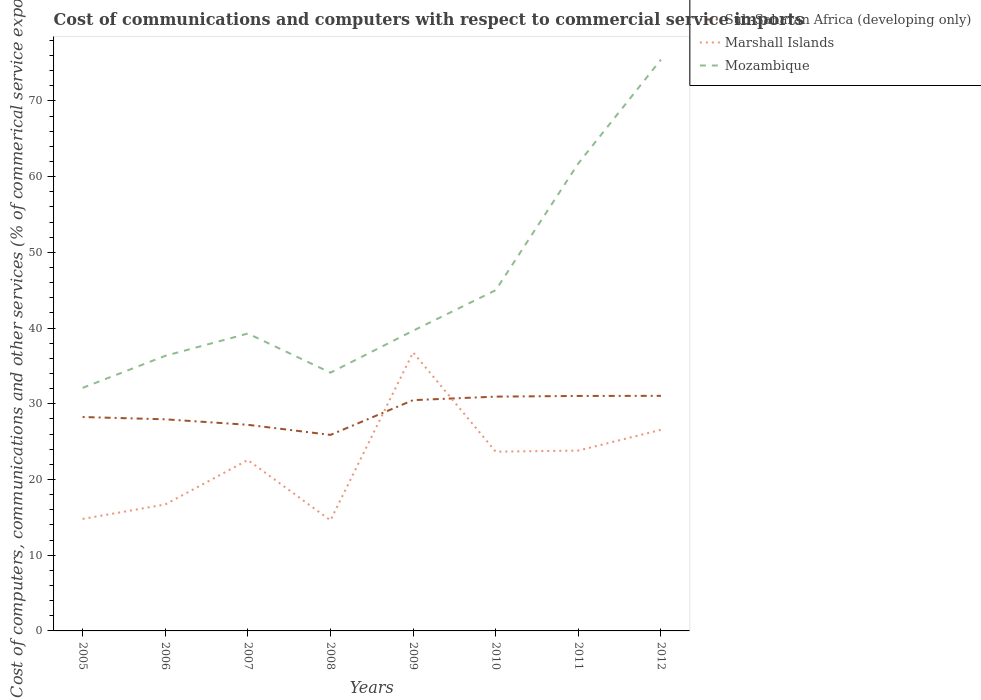Across all years, what is the maximum cost of communications and computers in Marshall Islands?
Ensure brevity in your answer.  14.61. In which year was the cost of communications and computers in Mozambique maximum?
Ensure brevity in your answer.  2005. What is the total cost of communications and computers in Sub-Saharan Africa (developing only) in the graph?
Your response must be concise. -3.1. What is the difference between the highest and the second highest cost of communications and computers in Marshall Islands?
Your response must be concise. 22.18. Is the cost of communications and computers in Marshall Islands strictly greater than the cost of communications and computers in Mozambique over the years?
Keep it short and to the point. Yes. How many lines are there?
Ensure brevity in your answer.  3. How many years are there in the graph?
Your response must be concise. 8. What is the difference between two consecutive major ticks on the Y-axis?
Your response must be concise. 10. Are the values on the major ticks of Y-axis written in scientific E-notation?
Keep it short and to the point. No. Does the graph contain any zero values?
Your answer should be very brief. No. Does the graph contain grids?
Give a very brief answer. No. Where does the legend appear in the graph?
Provide a short and direct response. Top right. How are the legend labels stacked?
Keep it short and to the point. Vertical. What is the title of the graph?
Your answer should be compact. Cost of communications and computers with respect to commercial service imports. What is the label or title of the X-axis?
Ensure brevity in your answer.  Years. What is the label or title of the Y-axis?
Your response must be concise. Cost of computers, communications and other services (% of commerical service exports). What is the Cost of computers, communications and other services (% of commerical service exports) in Sub-Saharan Africa (developing only) in 2005?
Your answer should be very brief. 28.25. What is the Cost of computers, communications and other services (% of commerical service exports) of Marshall Islands in 2005?
Your answer should be compact. 14.79. What is the Cost of computers, communications and other services (% of commerical service exports) of Mozambique in 2005?
Your response must be concise. 32.1. What is the Cost of computers, communications and other services (% of commerical service exports) in Sub-Saharan Africa (developing only) in 2006?
Offer a terse response. 27.95. What is the Cost of computers, communications and other services (% of commerical service exports) in Marshall Islands in 2006?
Give a very brief answer. 16.7. What is the Cost of computers, communications and other services (% of commerical service exports) of Mozambique in 2006?
Your answer should be very brief. 36.33. What is the Cost of computers, communications and other services (% of commerical service exports) in Sub-Saharan Africa (developing only) in 2007?
Your answer should be compact. 27.22. What is the Cost of computers, communications and other services (% of commerical service exports) in Marshall Islands in 2007?
Your answer should be very brief. 22.57. What is the Cost of computers, communications and other services (% of commerical service exports) of Mozambique in 2007?
Your response must be concise. 39.27. What is the Cost of computers, communications and other services (% of commerical service exports) in Sub-Saharan Africa (developing only) in 2008?
Provide a short and direct response. 25.89. What is the Cost of computers, communications and other services (% of commerical service exports) in Marshall Islands in 2008?
Your answer should be very brief. 14.61. What is the Cost of computers, communications and other services (% of commerical service exports) in Mozambique in 2008?
Give a very brief answer. 34.11. What is the Cost of computers, communications and other services (% of commerical service exports) in Sub-Saharan Africa (developing only) in 2009?
Provide a short and direct response. 30.48. What is the Cost of computers, communications and other services (% of commerical service exports) in Marshall Islands in 2009?
Give a very brief answer. 36.79. What is the Cost of computers, communications and other services (% of commerical service exports) in Mozambique in 2009?
Your answer should be compact. 39.64. What is the Cost of computers, communications and other services (% of commerical service exports) of Sub-Saharan Africa (developing only) in 2010?
Make the answer very short. 30.94. What is the Cost of computers, communications and other services (% of commerical service exports) of Marshall Islands in 2010?
Your answer should be compact. 23.67. What is the Cost of computers, communications and other services (% of commerical service exports) in Mozambique in 2010?
Give a very brief answer. 45. What is the Cost of computers, communications and other services (% of commerical service exports) of Sub-Saharan Africa (developing only) in 2011?
Provide a short and direct response. 31.03. What is the Cost of computers, communications and other services (% of commerical service exports) of Marshall Islands in 2011?
Offer a terse response. 23.82. What is the Cost of computers, communications and other services (% of commerical service exports) in Mozambique in 2011?
Provide a short and direct response. 61.74. What is the Cost of computers, communications and other services (% of commerical service exports) of Sub-Saharan Africa (developing only) in 2012?
Give a very brief answer. 31.05. What is the Cost of computers, communications and other services (% of commerical service exports) in Marshall Islands in 2012?
Provide a short and direct response. 26.56. What is the Cost of computers, communications and other services (% of commerical service exports) of Mozambique in 2012?
Keep it short and to the point. 75.45. Across all years, what is the maximum Cost of computers, communications and other services (% of commerical service exports) of Sub-Saharan Africa (developing only)?
Give a very brief answer. 31.05. Across all years, what is the maximum Cost of computers, communications and other services (% of commerical service exports) of Marshall Islands?
Provide a short and direct response. 36.79. Across all years, what is the maximum Cost of computers, communications and other services (% of commerical service exports) in Mozambique?
Your answer should be very brief. 75.45. Across all years, what is the minimum Cost of computers, communications and other services (% of commerical service exports) of Sub-Saharan Africa (developing only)?
Your answer should be compact. 25.89. Across all years, what is the minimum Cost of computers, communications and other services (% of commerical service exports) of Marshall Islands?
Provide a short and direct response. 14.61. Across all years, what is the minimum Cost of computers, communications and other services (% of commerical service exports) in Mozambique?
Your answer should be compact. 32.1. What is the total Cost of computers, communications and other services (% of commerical service exports) in Sub-Saharan Africa (developing only) in the graph?
Offer a very short reply. 232.8. What is the total Cost of computers, communications and other services (% of commerical service exports) of Marshall Islands in the graph?
Offer a terse response. 179.5. What is the total Cost of computers, communications and other services (% of commerical service exports) of Mozambique in the graph?
Provide a short and direct response. 363.64. What is the difference between the Cost of computers, communications and other services (% of commerical service exports) in Sub-Saharan Africa (developing only) in 2005 and that in 2006?
Your response must be concise. 0.3. What is the difference between the Cost of computers, communications and other services (% of commerical service exports) in Marshall Islands in 2005 and that in 2006?
Your response must be concise. -1.91. What is the difference between the Cost of computers, communications and other services (% of commerical service exports) of Mozambique in 2005 and that in 2006?
Provide a succinct answer. -4.23. What is the difference between the Cost of computers, communications and other services (% of commerical service exports) in Sub-Saharan Africa (developing only) in 2005 and that in 2007?
Ensure brevity in your answer.  1.03. What is the difference between the Cost of computers, communications and other services (% of commerical service exports) in Marshall Islands in 2005 and that in 2007?
Provide a short and direct response. -7.79. What is the difference between the Cost of computers, communications and other services (% of commerical service exports) in Mozambique in 2005 and that in 2007?
Give a very brief answer. -7.17. What is the difference between the Cost of computers, communications and other services (% of commerical service exports) in Sub-Saharan Africa (developing only) in 2005 and that in 2008?
Provide a succinct answer. 2.36. What is the difference between the Cost of computers, communications and other services (% of commerical service exports) in Marshall Islands in 2005 and that in 2008?
Make the answer very short. 0.18. What is the difference between the Cost of computers, communications and other services (% of commerical service exports) of Mozambique in 2005 and that in 2008?
Make the answer very short. -2.01. What is the difference between the Cost of computers, communications and other services (% of commerical service exports) in Sub-Saharan Africa (developing only) in 2005 and that in 2009?
Give a very brief answer. -2.23. What is the difference between the Cost of computers, communications and other services (% of commerical service exports) of Marshall Islands in 2005 and that in 2009?
Provide a succinct answer. -22. What is the difference between the Cost of computers, communications and other services (% of commerical service exports) in Mozambique in 2005 and that in 2009?
Provide a succinct answer. -7.54. What is the difference between the Cost of computers, communications and other services (% of commerical service exports) in Sub-Saharan Africa (developing only) in 2005 and that in 2010?
Offer a terse response. -2.69. What is the difference between the Cost of computers, communications and other services (% of commerical service exports) in Marshall Islands in 2005 and that in 2010?
Keep it short and to the point. -8.88. What is the difference between the Cost of computers, communications and other services (% of commerical service exports) of Sub-Saharan Africa (developing only) in 2005 and that in 2011?
Provide a succinct answer. -2.78. What is the difference between the Cost of computers, communications and other services (% of commerical service exports) in Marshall Islands in 2005 and that in 2011?
Provide a short and direct response. -9.03. What is the difference between the Cost of computers, communications and other services (% of commerical service exports) in Mozambique in 2005 and that in 2011?
Your answer should be compact. -29.64. What is the difference between the Cost of computers, communications and other services (% of commerical service exports) of Sub-Saharan Africa (developing only) in 2005 and that in 2012?
Offer a very short reply. -2.8. What is the difference between the Cost of computers, communications and other services (% of commerical service exports) in Marshall Islands in 2005 and that in 2012?
Your answer should be very brief. -11.77. What is the difference between the Cost of computers, communications and other services (% of commerical service exports) in Mozambique in 2005 and that in 2012?
Keep it short and to the point. -43.35. What is the difference between the Cost of computers, communications and other services (% of commerical service exports) of Sub-Saharan Africa (developing only) in 2006 and that in 2007?
Offer a very short reply. 0.73. What is the difference between the Cost of computers, communications and other services (% of commerical service exports) in Marshall Islands in 2006 and that in 2007?
Make the answer very short. -5.87. What is the difference between the Cost of computers, communications and other services (% of commerical service exports) of Mozambique in 2006 and that in 2007?
Offer a terse response. -2.94. What is the difference between the Cost of computers, communications and other services (% of commerical service exports) of Sub-Saharan Africa (developing only) in 2006 and that in 2008?
Keep it short and to the point. 2.06. What is the difference between the Cost of computers, communications and other services (% of commerical service exports) of Marshall Islands in 2006 and that in 2008?
Provide a short and direct response. 2.1. What is the difference between the Cost of computers, communications and other services (% of commerical service exports) of Mozambique in 2006 and that in 2008?
Offer a terse response. 2.22. What is the difference between the Cost of computers, communications and other services (% of commerical service exports) of Sub-Saharan Africa (developing only) in 2006 and that in 2009?
Make the answer very short. -2.53. What is the difference between the Cost of computers, communications and other services (% of commerical service exports) in Marshall Islands in 2006 and that in 2009?
Make the answer very short. -20.09. What is the difference between the Cost of computers, communications and other services (% of commerical service exports) in Mozambique in 2006 and that in 2009?
Provide a succinct answer. -3.31. What is the difference between the Cost of computers, communications and other services (% of commerical service exports) in Sub-Saharan Africa (developing only) in 2006 and that in 2010?
Offer a terse response. -3. What is the difference between the Cost of computers, communications and other services (% of commerical service exports) in Marshall Islands in 2006 and that in 2010?
Your answer should be compact. -6.97. What is the difference between the Cost of computers, communications and other services (% of commerical service exports) in Mozambique in 2006 and that in 2010?
Make the answer very short. -8.67. What is the difference between the Cost of computers, communications and other services (% of commerical service exports) of Sub-Saharan Africa (developing only) in 2006 and that in 2011?
Your response must be concise. -3.09. What is the difference between the Cost of computers, communications and other services (% of commerical service exports) of Marshall Islands in 2006 and that in 2011?
Provide a short and direct response. -7.11. What is the difference between the Cost of computers, communications and other services (% of commerical service exports) of Mozambique in 2006 and that in 2011?
Ensure brevity in your answer.  -25.41. What is the difference between the Cost of computers, communications and other services (% of commerical service exports) in Sub-Saharan Africa (developing only) in 2006 and that in 2012?
Provide a succinct answer. -3.1. What is the difference between the Cost of computers, communications and other services (% of commerical service exports) of Marshall Islands in 2006 and that in 2012?
Offer a very short reply. -9.86. What is the difference between the Cost of computers, communications and other services (% of commerical service exports) in Mozambique in 2006 and that in 2012?
Your response must be concise. -39.12. What is the difference between the Cost of computers, communications and other services (% of commerical service exports) of Sub-Saharan Africa (developing only) in 2007 and that in 2008?
Make the answer very short. 1.33. What is the difference between the Cost of computers, communications and other services (% of commerical service exports) of Marshall Islands in 2007 and that in 2008?
Make the answer very short. 7.97. What is the difference between the Cost of computers, communications and other services (% of commerical service exports) in Mozambique in 2007 and that in 2008?
Offer a terse response. 5.17. What is the difference between the Cost of computers, communications and other services (% of commerical service exports) of Sub-Saharan Africa (developing only) in 2007 and that in 2009?
Your response must be concise. -3.26. What is the difference between the Cost of computers, communications and other services (% of commerical service exports) of Marshall Islands in 2007 and that in 2009?
Your answer should be compact. -14.21. What is the difference between the Cost of computers, communications and other services (% of commerical service exports) of Mozambique in 2007 and that in 2009?
Offer a very short reply. -0.37. What is the difference between the Cost of computers, communications and other services (% of commerical service exports) in Sub-Saharan Africa (developing only) in 2007 and that in 2010?
Give a very brief answer. -3.72. What is the difference between the Cost of computers, communications and other services (% of commerical service exports) of Marshall Islands in 2007 and that in 2010?
Ensure brevity in your answer.  -1.09. What is the difference between the Cost of computers, communications and other services (% of commerical service exports) in Mozambique in 2007 and that in 2010?
Ensure brevity in your answer.  -5.73. What is the difference between the Cost of computers, communications and other services (% of commerical service exports) of Sub-Saharan Africa (developing only) in 2007 and that in 2011?
Give a very brief answer. -3.81. What is the difference between the Cost of computers, communications and other services (% of commerical service exports) of Marshall Islands in 2007 and that in 2011?
Your response must be concise. -1.24. What is the difference between the Cost of computers, communications and other services (% of commerical service exports) of Mozambique in 2007 and that in 2011?
Give a very brief answer. -22.47. What is the difference between the Cost of computers, communications and other services (% of commerical service exports) of Sub-Saharan Africa (developing only) in 2007 and that in 2012?
Provide a succinct answer. -3.83. What is the difference between the Cost of computers, communications and other services (% of commerical service exports) of Marshall Islands in 2007 and that in 2012?
Your answer should be compact. -3.99. What is the difference between the Cost of computers, communications and other services (% of commerical service exports) of Mozambique in 2007 and that in 2012?
Offer a very short reply. -36.18. What is the difference between the Cost of computers, communications and other services (% of commerical service exports) in Sub-Saharan Africa (developing only) in 2008 and that in 2009?
Your answer should be compact. -4.59. What is the difference between the Cost of computers, communications and other services (% of commerical service exports) in Marshall Islands in 2008 and that in 2009?
Your response must be concise. -22.18. What is the difference between the Cost of computers, communications and other services (% of commerical service exports) in Mozambique in 2008 and that in 2009?
Provide a succinct answer. -5.54. What is the difference between the Cost of computers, communications and other services (% of commerical service exports) in Sub-Saharan Africa (developing only) in 2008 and that in 2010?
Your response must be concise. -5.05. What is the difference between the Cost of computers, communications and other services (% of commerical service exports) in Marshall Islands in 2008 and that in 2010?
Your answer should be compact. -9.06. What is the difference between the Cost of computers, communications and other services (% of commerical service exports) of Mozambique in 2008 and that in 2010?
Ensure brevity in your answer.  -10.89. What is the difference between the Cost of computers, communications and other services (% of commerical service exports) of Sub-Saharan Africa (developing only) in 2008 and that in 2011?
Provide a succinct answer. -5.14. What is the difference between the Cost of computers, communications and other services (% of commerical service exports) of Marshall Islands in 2008 and that in 2011?
Offer a terse response. -9.21. What is the difference between the Cost of computers, communications and other services (% of commerical service exports) in Mozambique in 2008 and that in 2011?
Give a very brief answer. -27.63. What is the difference between the Cost of computers, communications and other services (% of commerical service exports) in Sub-Saharan Africa (developing only) in 2008 and that in 2012?
Keep it short and to the point. -5.16. What is the difference between the Cost of computers, communications and other services (% of commerical service exports) in Marshall Islands in 2008 and that in 2012?
Your answer should be compact. -11.95. What is the difference between the Cost of computers, communications and other services (% of commerical service exports) of Mozambique in 2008 and that in 2012?
Your response must be concise. -41.34. What is the difference between the Cost of computers, communications and other services (% of commerical service exports) of Sub-Saharan Africa (developing only) in 2009 and that in 2010?
Offer a terse response. -0.46. What is the difference between the Cost of computers, communications and other services (% of commerical service exports) of Marshall Islands in 2009 and that in 2010?
Make the answer very short. 13.12. What is the difference between the Cost of computers, communications and other services (% of commerical service exports) of Mozambique in 2009 and that in 2010?
Your response must be concise. -5.36. What is the difference between the Cost of computers, communications and other services (% of commerical service exports) of Sub-Saharan Africa (developing only) in 2009 and that in 2011?
Make the answer very short. -0.55. What is the difference between the Cost of computers, communications and other services (% of commerical service exports) in Marshall Islands in 2009 and that in 2011?
Your answer should be very brief. 12.97. What is the difference between the Cost of computers, communications and other services (% of commerical service exports) in Mozambique in 2009 and that in 2011?
Ensure brevity in your answer.  -22.1. What is the difference between the Cost of computers, communications and other services (% of commerical service exports) of Sub-Saharan Africa (developing only) in 2009 and that in 2012?
Provide a short and direct response. -0.57. What is the difference between the Cost of computers, communications and other services (% of commerical service exports) in Marshall Islands in 2009 and that in 2012?
Provide a succinct answer. 10.23. What is the difference between the Cost of computers, communications and other services (% of commerical service exports) in Mozambique in 2009 and that in 2012?
Give a very brief answer. -35.81. What is the difference between the Cost of computers, communications and other services (% of commerical service exports) of Sub-Saharan Africa (developing only) in 2010 and that in 2011?
Make the answer very short. -0.09. What is the difference between the Cost of computers, communications and other services (% of commerical service exports) in Marshall Islands in 2010 and that in 2011?
Your answer should be compact. -0.15. What is the difference between the Cost of computers, communications and other services (% of commerical service exports) of Mozambique in 2010 and that in 2011?
Provide a succinct answer. -16.74. What is the difference between the Cost of computers, communications and other services (% of commerical service exports) of Sub-Saharan Africa (developing only) in 2010 and that in 2012?
Your response must be concise. -0.1. What is the difference between the Cost of computers, communications and other services (% of commerical service exports) in Marshall Islands in 2010 and that in 2012?
Your response must be concise. -2.89. What is the difference between the Cost of computers, communications and other services (% of commerical service exports) of Mozambique in 2010 and that in 2012?
Ensure brevity in your answer.  -30.45. What is the difference between the Cost of computers, communications and other services (% of commerical service exports) of Sub-Saharan Africa (developing only) in 2011 and that in 2012?
Ensure brevity in your answer.  -0.01. What is the difference between the Cost of computers, communications and other services (% of commerical service exports) in Marshall Islands in 2011 and that in 2012?
Your response must be concise. -2.74. What is the difference between the Cost of computers, communications and other services (% of commerical service exports) in Mozambique in 2011 and that in 2012?
Make the answer very short. -13.71. What is the difference between the Cost of computers, communications and other services (% of commerical service exports) in Sub-Saharan Africa (developing only) in 2005 and the Cost of computers, communications and other services (% of commerical service exports) in Marshall Islands in 2006?
Make the answer very short. 11.55. What is the difference between the Cost of computers, communications and other services (% of commerical service exports) in Sub-Saharan Africa (developing only) in 2005 and the Cost of computers, communications and other services (% of commerical service exports) in Mozambique in 2006?
Your response must be concise. -8.08. What is the difference between the Cost of computers, communications and other services (% of commerical service exports) in Marshall Islands in 2005 and the Cost of computers, communications and other services (% of commerical service exports) in Mozambique in 2006?
Your answer should be compact. -21.54. What is the difference between the Cost of computers, communications and other services (% of commerical service exports) in Sub-Saharan Africa (developing only) in 2005 and the Cost of computers, communications and other services (% of commerical service exports) in Marshall Islands in 2007?
Ensure brevity in your answer.  5.67. What is the difference between the Cost of computers, communications and other services (% of commerical service exports) in Sub-Saharan Africa (developing only) in 2005 and the Cost of computers, communications and other services (% of commerical service exports) in Mozambique in 2007?
Ensure brevity in your answer.  -11.02. What is the difference between the Cost of computers, communications and other services (% of commerical service exports) in Marshall Islands in 2005 and the Cost of computers, communications and other services (% of commerical service exports) in Mozambique in 2007?
Provide a succinct answer. -24.49. What is the difference between the Cost of computers, communications and other services (% of commerical service exports) of Sub-Saharan Africa (developing only) in 2005 and the Cost of computers, communications and other services (% of commerical service exports) of Marshall Islands in 2008?
Provide a succinct answer. 13.64. What is the difference between the Cost of computers, communications and other services (% of commerical service exports) of Sub-Saharan Africa (developing only) in 2005 and the Cost of computers, communications and other services (% of commerical service exports) of Mozambique in 2008?
Keep it short and to the point. -5.86. What is the difference between the Cost of computers, communications and other services (% of commerical service exports) in Marshall Islands in 2005 and the Cost of computers, communications and other services (% of commerical service exports) in Mozambique in 2008?
Keep it short and to the point. -19.32. What is the difference between the Cost of computers, communications and other services (% of commerical service exports) of Sub-Saharan Africa (developing only) in 2005 and the Cost of computers, communications and other services (% of commerical service exports) of Marshall Islands in 2009?
Offer a terse response. -8.54. What is the difference between the Cost of computers, communications and other services (% of commerical service exports) of Sub-Saharan Africa (developing only) in 2005 and the Cost of computers, communications and other services (% of commerical service exports) of Mozambique in 2009?
Provide a short and direct response. -11.39. What is the difference between the Cost of computers, communications and other services (% of commerical service exports) in Marshall Islands in 2005 and the Cost of computers, communications and other services (% of commerical service exports) in Mozambique in 2009?
Provide a short and direct response. -24.85. What is the difference between the Cost of computers, communications and other services (% of commerical service exports) in Sub-Saharan Africa (developing only) in 2005 and the Cost of computers, communications and other services (% of commerical service exports) in Marshall Islands in 2010?
Your answer should be compact. 4.58. What is the difference between the Cost of computers, communications and other services (% of commerical service exports) in Sub-Saharan Africa (developing only) in 2005 and the Cost of computers, communications and other services (% of commerical service exports) in Mozambique in 2010?
Give a very brief answer. -16.75. What is the difference between the Cost of computers, communications and other services (% of commerical service exports) of Marshall Islands in 2005 and the Cost of computers, communications and other services (% of commerical service exports) of Mozambique in 2010?
Your answer should be compact. -30.21. What is the difference between the Cost of computers, communications and other services (% of commerical service exports) in Sub-Saharan Africa (developing only) in 2005 and the Cost of computers, communications and other services (% of commerical service exports) in Marshall Islands in 2011?
Offer a very short reply. 4.43. What is the difference between the Cost of computers, communications and other services (% of commerical service exports) of Sub-Saharan Africa (developing only) in 2005 and the Cost of computers, communications and other services (% of commerical service exports) of Mozambique in 2011?
Your answer should be very brief. -33.49. What is the difference between the Cost of computers, communications and other services (% of commerical service exports) of Marshall Islands in 2005 and the Cost of computers, communications and other services (% of commerical service exports) of Mozambique in 2011?
Ensure brevity in your answer.  -46.95. What is the difference between the Cost of computers, communications and other services (% of commerical service exports) of Sub-Saharan Africa (developing only) in 2005 and the Cost of computers, communications and other services (% of commerical service exports) of Marshall Islands in 2012?
Your answer should be very brief. 1.69. What is the difference between the Cost of computers, communications and other services (% of commerical service exports) of Sub-Saharan Africa (developing only) in 2005 and the Cost of computers, communications and other services (% of commerical service exports) of Mozambique in 2012?
Ensure brevity in your answer.  -47.2. What is the difference between the Cost of computers, communications and other services (% of commerical service exports) in Marshall Islands in 2005 and the Cost of computers, communications and other services (% of commerical service exports) in Mozambique in 2012?
Offer a terse response. -60.66. What is the difference between the Cost of computers, communications and other services (% of commerical service exports) of Sub-Saharan Africa (developing only) in 2006 and the Cost of computers, communications and other services (% of commerical service exports) of Marshall Islands in 2007?
Your answer should be compact. 5.37. What is the difference between the Cost of computers, communications and other services (% of commerical service exports) of Sub-Saharan Africa (developing only) in 2006 and the Cost of computers, communications and other services (% of commerical service exports) of Mozambique in 2007?
Your answer should be compact. -11.33. What is the difference between the Cost of computers, communications and other services (% of commerical service exports) of Marshall Islands in 2006 and the Cost of computers, communications and other services (% of commerical service exports) of Mozambique in 2007?
Ensure brevity in your answer.  -22.57. What is the difference between the Cost of computers, communications and other services (% of commerical service exports) of Sub-Saharan Africa (developing only) in 2006 and the Cost of computers, communications and other services (% of commerical service exports) of Marshall Islands in 2008?
Provide a succinct answer. 13.34. What is the difference between the Cost of computers, communications and other services (% of commerical service exports) in Sub-Saharan Africa (developing only) in 2006 and the Cost of computers, communications and other services (% of commerical service exports) in Mozambique in 2008?
Your answer should be compact. -6.16. What is the difference between the Cost of computers, communications and other services (% of commerical service exports) in Marshall Islands in 2006 and the Cost of computers, communications and other services (% of commerical service exports) in Mozambique in 2008?
Give a very brief answer. -17.4. What is the difference between the Cost of computers, communications and other services (% of commerical service exports) in Sub-Saharan Africa (developing only) in 2006 and the Cost of computers, communications and other services (% of commerical service exports) in Marshall Islands in 2009?
Offer a very short reply. -8.84. What is the difference between the Cost of computers, communications and other services (% of commerical service exports) in Sub-Saharan Africa (developing only) in 2006 and the Cost of computers, communications and other services (% of commerical service exports) in Mozambique in 2009?
Keep it short and to the point. -11.7. What is the difference between the Cost of computers, communications and other services (% of commerical service exports) of Marshall Islands in 2006 and the Cost of computers, communications and other services (% of commerical service exports) of Mozambique in 2009?
Give a very brief answer. -22.94. What is the difference between the Cost of computers, communications and other services (% of commerical service exports) in Sub-Saharan Africa (developing only) in 2006 and the Cost of computers, communications and other services (% of commerical service exports) in Marshall Islands in 2010?
Your response must be concise. 4.28. What is the difference between the Cost of computers, communications and other services (% of commerical service exports) of Sub-Saharan Africa (developing only) in 2006 and the Cost of computers, communications and other services (% of commerical service exports) of Mozambique in 2010?
Make the answer very short. -17.05. What is the difference between the Cost of computers, communications and other services (% of commerical service exports) of Marshall Islands in 2006 and the Cost of computers, communications and other services (% of commerical service exports) of Mozambique in 2010?
Your answer should be compact. -28.3. What is the difference between the Cost of computers, communications and other services (% of commerical service exports) of Sub-Saharan Africa (developing only) in 2006 and the Cost of computers, communications and other services (% of commerical service exports) of Marshall Islands in 2011?
Provide a short and direct response. 4.13. What is the difference between the Cost of computers, communications and other services (% of commerical service exports) in Sub-Saharan Africa (developing only) in 2006 and the Cost of computers, communications and other services (% of commerical service exports) in Mozambique in 2011?
Make the answer very short. -33.79. What is the difference between the Cost of computers, communications and other services (% of commerical service exports) in Marshall Islands in 2006 and the Cost of computers, communications and other services (% of commerical service exports) in Mozambique in 2011?
Keep it short and to the point. -45.04. What is the difference between the Cost of computers, communications and other services (% of commerical service exports) in Sub-Saharan Africa (developing only) in 2006 and the Cost of computers, communications and other services (% of commerical service exports) in Marshall Islands in 2012?
Give a very brief answer. 1.39. What is the difference between the Cost of computers, communications and other services (% of commerical service exports) of Sub-Saharan Africa (developing only) in 2006 and the Cost of computers, communications and other services (% of commerical service exports) of Mozambique in 2012?
Your answer should be very brief. -47.5. What is the difference between the Cost of computers, communications and other services (% of commerical service exports) in Marshall Islands in 2006 and the Cost of computers, communications and other services (% of commerical service exports) in Mozambique in 2012?
Offer a very short reply. -58.75. What is the difference between the Cost of computers, communications and other services (% of commerical service exports) of Sub-Saharan Africa (developing only) in 2007 and the Cost of computers, communications and other services (% of commerical service exports) of Marshall Islands in 2008?
Provide a succinct answer. 12.61. What is the difference between the Cost of computers, communications and other services (% of commerical service exports) of Sub-Saharan Africa (developing only) in 2007 and the Cost of computers, communications and other services (% of commerical service exports) of Mozambique in 2008?
Make the answer very short. -6.89. What is the difference between the Cost of computers, communications and other services (% of commerical service exports) in Marshall Islands in 2007 and the Cost of computers, communications and other services (% of commerical service exports) in Mozambique in 2008?
Provide a succinct answer. -11.53. What is the difference between the Cost of computers, communications and other services (% of commerical service exports) in Sub-Saharan Africa (developing only) in 2007 and the Cost of computers, communications and other services (% of commerical service exports) in Marshall Islands in 2009?
Your answer should be compact. -9.57. What is the difference between the Cost of computers, communications and other services (% of commerical service exports) of Sub-Saharan Africa (developing only) in 2007 and the Cost of computers, communications and other services (% of commerical service exports) of Mozambique in 2009?
Your response must be concise. -12.42. What is the difference between the Cost of computers, communications and other services (% of commerical service exports) in Marshall Islands in 2007 and the Cost of computers, communications and other services (% of commerical service exports) in Mozambique in 2009?
Make the answer very short. -17.07. What is the difference between the Cost of computers, communications and other services (% of commerical service exports) of Sub-Saharan Africa (developing only) in 2007 and the Cost of computers, communications and other services (% of commerical service exports) of Marshall Islands in 2010?
Offer a terse response. 3.55. What is the difference between the Cost of computers, communications and other services (% of commerical service exports) of Sub-Saharan Africa (developing only) in 2007 and the Cost of computers, communications and other services (% of commerical service exports) of Mozambique in 2010?
Make the answer very short. -17.78. What is the difference between the Cost of computers, communications and other services (% of commerical service exports) of Marshall Islands in 2007 and the Cost of computers, communications and other services (% of commerical service exports) of Mozambique in 2010?
Keep it short and to the point. -22.42. What is the difference between the Cost of computers, communications and other services (% of commerical service exports) in Sub-Saharan Africa (developing only) in 2007 and the Cost of computers, communications and other services (% of commerical service exports) in Marshall Islands in 2011?
Offer a very short reply. 3.4. What is the difference between the Cost of computers, communications and other services (% of commerical service exports) in Sub-Saharan Africa (developing only) in 2007 and the Cost of computers, communications and other services (% of commerical service exports) in Mozambique in 2011?
Give a very brief answer. -34.52. What is the difference between the Cost of computers, communications and other services (% of commerical service exports) of Marshall Islands in 2007 and the Cost of computers, communications and other services (% of commerical service exports) of Mozambique in 2011?
Provide a succinct answer. -39.17. What is the difference between the Cost of computers, communications and other services (% of commerical service exports) of Sub-Saharan Africa (developing only) in 2007 and the Cost of computers, communications and other services (% of commerical service exports) of Marshall Islands in 2012?
Offer a very short reply. 0.66. What is the difference between the Cost of computers, communications and other services (% of commerical service exports) in Sub-Saharan Africa (developing only) in 2007 and the Cost of computers, communications and other services (% of commerical service exports) in Mozambique in 2012?
Give a very brief answer. -48.23. What is the difference between the Cost of computers, communications and other services (% of commerical service exports) of Marshall Islands in 2007 and the Cost of computers, communications and other services (% of commerical service exports) of Mozambique in 2012?
Give a very brief answer. -52.88. What is the difference between the Cost of computers, communications and other services (% of commerical service exports) of Sub-Saharan Africa (developing only) in 2008 and the Cost of computers, communications and other services (% of commerical service exports) of Marshall Islands in 2009?
Ensure brevity in your answer.  -10.9. What is the difference between the Cost of computers, communications and other services (% of commerical service exports) of Sub-Saharan Africa (developing only) in 2008 and the Cost of computers, communications and other services (% of commerical service exports) of Mozambique in 2009?
Provide a short and direct response. -13.75. What is the difference between the Cost of computers, communications and other services (% of commerical service exports) in Marshall Islands in 2008 and the Cost of computers, communications and other services (% of commerical service exports) in Mozambique in 2009?
Provide a succinct answer. -25.04. What is the difference between the Cost of computers, communications and other services (% of commerical service exports) of Sub-Saharan Africa (developing only) in 2008 and the Cost of computers, communications and other services (% of commerical service exports) of Marshall Islands in 2010?
Offer a terse response. 2.22. What is the difference between the Cost of computers, communications and other services (% of commerical service exports) of Sub-Saharan Africa (developing only) in 2008 and the Cost of computers, communications and other services (% of commerical service exports) of Mozambique in 2010?
Ensure brevity in your answer.  -19.11. What is the difference between the Cost of computers, communications and other services (% of commerical service exports) in Marshall Islands in 2008 and the Cost of computers, communications and other services (% of commerical service exports) in Mozambique in 2010?
Offer a terse response. -30.39. What is the difference between the Cost of computers, communications and other services (% of commerical service exports) of Sub-Saharan Africa (developing only) in 2008 and the Cost of computers, communications and other services (% of commerical service exports) of Marshall Islands in 2011?
Offer a terse response. 2.07. What is the difference between the Cost of computers, communications and other services (% of commerical service exports) of Sub-Saharan Africa (developing only) in 2008 and the Cost of computers, communications and other services (% of commerical service exports) of Mozambique in 2011?
Provide a succinct answer. -35.85. What is the difference between the Cost of computers, communications and other services (% of commerical service exports) of Marshall Islands in 2008 and the Cost of computers, communications and other services (% of commerical service exports) of Mozambique in 2011?
Ensure brevity in your answer.  -47.13. What is the difference between the Cost of computers, communications and other services (% of commerical service exports) of Sub-Saharan Africa (developing only) in 2008 and the Cost of computers, communications and other services (% of commerical service exports) of Marshall Islands in 2012?
Make the answer very short. -0.67. What is the difference between the Cost of computers, communications and other services (% of commerical service exports) of Sub-Saharan Africa (developing only) in 2008 and the Cost of computers, communications and other services (% of commerical service exports) of Mozambique in 2012?
Ensure brevity in your answer.  -49.56. What is the difference between the Cost of computers, communications and other services (% of commerical service exports) of Marshall Islands in 2008 and the Cost of computers, communications and other services (% of commerical service exports) of Mozambique in 2012?
Your answer should be compact. -60.84. What is the difference between the Cost of computers, communications and other services (% of commerical service exports) in Sub-Saharan Africa (developing only) in 2009 and the Cost of computers, communications and other services (% of commerical service exports) in Marshall Islands in 2010?
Offer a terse response. 6.81. What is the difference between the Cost of computers, communications and other services (% of commerical service exports) of Sub-Saharan Africa (developing only) in 2009 and the Cost of computers, communications and other services (% of commerical service exports) of Mozambique in 2010?
Give a very brief answer. -14.52. What is the difference between the Cost of computers, communications and other services (% of commerical service exports) in Marshall Islands in 2009 and the Cost of computers, communications and other services (% of commerical service exports) in Mozambique in 2010?
Provide a short and direct response. -8.21. What is the difference between the Cost of computers, communications and other services (% of commerical service exports) in Sub-Saharan Africa (developing only) in 2009 and the Cost of computers, communications and other services (% of commerical service exports) in Marshall Islands in 2011?
Your answer should be very brief. 6.66. What is the difference between the Cost of computers, communications and other services (% of commerical service exports) of Sub-Saharan Africa (developing only) in 2009 and the Cost of computers, communications and other services (% of commerical service exports) of Mozambique in 2011?
Your response must be concise. -31.26. What is the difference between the Cost of computers, communications and other services (% of commerical service exports) of Marshall Islands in 2009 and the Cost of computers, communications and other services (% of commerical service exports) of Mozambique in 2011?
Provide a short and direct response. -24.95. What is the difference between the Cost of computers, communications and other services (% of commerical service exports) of Sub-Saharan Africa (developing only) in 2009 and the Cost of computers, communications and other services (% of commerical service exports) of Marshall Islands in 2012?
Your response must be concise. 3.92. What is the difference between the Cost of computers, communications and other services (% of commerical service exports) of Sub-Saharan Africa (developing only) in 2009 and the Cost of computers, communications and other services (% of commerical service exports) of Mozambique in 2012?
Offer a terse response. -44.97. What is the difference between the Cost of computers, communications and other services (% of commerical service exports) in Marshall Islands in 2009 and the Cost of computers, communications and other services (% of commerical service exports) in Mozambique in 2012?
Offer a very short reply. -38.66. What is the difference between the Cost of computers, communications and other services (% of commerical service exports) of Sub-Saharan Africa (developing only) in 2010 and the Cost of computers, communications and other services (% of commerical service exports) of Marshall Islands in 2011?
Your answer should be very brief. 7.13. What is the difference between the Cost of computers, communications and other services (% of commerical service exports) of Sub-Saharan Africa (developing only) in 2010 and the Cost of computers, communications and other services (% of commerical service exports) of Mozambique in 2011?
Provide a succinct answer. -30.8. What is the difference between the Cost of computers, communications and other services (% of commerical service exports) of Marshall Islands in 2010 and the Cost of computers, communications and other services (% of commerical service exports) of Mozambique in 2011?
Your response must be concise. -38.07. What is the difference between the Cost of computers, communications and other services (% of commerical service exports) in Sub-Saharan Africa (developing only) in 2010 and the Cost of computers, communications and other services (% of commerical service exports) in Marshall Islands in 2012?
Make the answer very short. 4.38. What is the difference between the Cost of computers, communications and other services (% of commerical service exports) in Sub-Saharan Africa (developing only) in 2010 and the Cost of computers, communications and other services (% of commerical service exports) in Mozambique in 2012?
Your response must be concise. -44.51. What is the difference between the Cost of computers, communications and other services (% of commerical service exports) in Marshall Islands in 2010 and the Cost of computers, communications and other services (% of commerical service exports) in Mozambique in 2012?
Your answer should be very brief. -51.78. What is the difference between the Cost of computers, communications and other services (% of commerical service exports) of Sub-Saharan Africa (developing only) in 2011 and the Cost of computers, communications and other services (% of commerical service exports) of Marshall Islands in 2012?
Your response must be concise. 4.47. What is the difference between the Cost of computers, communications and other services (% of commerical service exports) in Sub-Saharan Africa (developing only) in 2011 and the Cost of computers, communications and other services (% of commerical service exports) in Mozambique in 2012?
Your answer should be compact. -44.42. What is the difference between the Cost of computers, communications and other services (% of commerical service exports) of Marshall Islands in 2011 and the Cost of computers, communications and other services (% of commerical service exports) of Mozambique in 2012?
Your response must be concise. -51.63. What is the average Cost of computers, communications and other services (% of commerical service exports) in Sub-Saharan Africa (developing only) per year?
Make the answer very short. 29.1. What is the average Cost of computers, communications and other services (% of commerical service exports) in Marshall Islands per year?
Make the answer very short. 22.44. What is the average Cost of computers, communications and other services (% of commerical service exports) of Mozambique per year?
Provide a succinct answer. 45.45. In the year 2005, what is the difference between the Cost of computers, communications and other services (% of commerical service exports) in Sub-Saharan Africa (developing only) and Cost of computers, communications and other services (% of commerical service exports) in Marshall Islands?
Keep it short and to the point. 13.46. In the year 2005, what is the difference between the Cost of computers, communications and other services (% of commerical service exports) in Sub-Saharan Africa (developing only) and Cost of computers, communications and other services (% of commerical service exports) in Mozambique?
Make the answer very short. -3.85. In the year 2005, what is the difference between the Cost of computers, communications and other services (% of commerical service exports) in Marshall Islands and Cost of computers, communications and other services (% of commerical service exports) in Mozambique?
Ensure brevity in your answer.  -17.31. In the year 2006, what is the difference between the Cost of computers, communications and other services (% of commerical service exports) in Sub-Saharan Africa (developing only) and Cost of computers, communications and other services (% of commerical service exports) in Marshall Islands?
Your response must be concise. 11.24. In the year 2006, what is the difference between the Cost of computers, communications and other services (% of commerical service exports) in Sub-Saharan Africa (developing only) and Cost of computers, communications and other services (% of commerical service exports) in Mozambique?
Offer a terse response. -8.38. In the year 2006, what is the difference between the Cost of computers, communications and other services (% of commerical service exports) in Marshall Islands and Cost of computers, communications and other services (% of commerical service exports) in Mozambique?
Ensure brevity in your answer.  -19.63. In the year 2007, what is the difference between the Cost of computers, communications and other services (% of commerical service exports) in Sub-Saharan Africa (developing only) and Cost of computers, communications and other services (% of commerical service exports) in Marshall Islands?
Your response must be concise. 4.65. In the year 2007, what is the difference between the Cost of computers, communications and other services (% of commerical service exports) of Sub-Saharan Africa (developing only) and Cost of computers, communications and other services (% of commerical service exports) of Mozambique?
Your response must be concise. -12.05. In the year 2007, what is the difference between the Cost of computers, communications and other services (% of commerical service exports) of Marshall Islands and Cost of computers, communications and other services (% of commerical service exports) of Mozambique?
Your response must be concise. -16.7. In the year 2008, what is the difference between the Cost of computers, communications and other services (% of commerical service exports) of Sub-Saharan Africa (developing only) and Cost of computers, communications and other services (% of commerical service exports) of Marshall Islands?
Your response must be concise. 11.28. In the year 2008, what is the difference between the Cost of computers, communications and other services (% of commerical service exports) in Sub-Saharan Africa (developing only) and Cost of computers, communications and other services (% of commerical service exports) in Mozambique?
Give a very brief answer. -8.22. In the year 2008, what is the difference between the Cost of computers, communications and other services (% of commerical service exports) of Marshall Islands and Cost of computers, communications and other services (% of commerical service exports) of Mozambique?
Provide a succinct answer. -19.5. In the year 2009, what is the difference between the Cost of computers, communications and other services (% of commerical service exports) in Sub-Saharan Africa (developing only) and Cost of computers, communications and other services (% of commerical service exports) in Marshall Islands?
Ensure brevity in your answer.  -6.31. In the year 2009, what is the difference between the Cost of computers, communications and other services (% of commerical service exports) of Sub-Saharan Africa (developing only) and Cost of computers, communications and other services (% of commerical service exports) of Mozambique?
Your answer should be very brief. -9.16. In the year 2009, what is the difference between the Cost of computers, communications and other services (% of commerical service exports) in Marshall Islands and Cost of computers, communications and other services (% of commerical service exports) in Mozambique?
Make the answer very short. -2.85. In the year 2010, what is the difference between the Cost of computers, communications and other services (% of commerical service exports) in Sub-Saharan Africa (developing only) and Cost of computers, communications and other services (% of commerical service exports) in Marshall Islands?
Keep it short and to the point. 7.27. In the year 2010, what is the difference between the Cost of computers, communications and other services (% of commerical service exports) of Sub-Saharan Africa (developing only) and Cost of computers, communications and other services (% of commerical service exports) of Mozambique?
Your answer should be compact. -14.06. In the year 2010, what is the difference between the Cost of computers, communications and other services (% of commerical service exports) in Marshall Islands and Cost of computers, communications and other services (% of commerical service exports) in Mozambique?
Provide a short and direct response. -21.33. In the year 2011, what is the difference between the Cost of computers, communications and other services (% of commerical service exports) of Sub-Saharan Africa (developing only) and Cost of computers, communications and other services (% of commerical service exports) of Marshall Islands?
Ensure brevity in your answer.  7.22. In the year 2011, what is the difference between the Cost of computers, communications and other services (% of commerical service exports) of Sub-Saharan Africa (developing only) and Cost of computers, communications and other services (% of commerical service exports) of Mozambique?
Offer a terse response. -30.71. In the year 2011, what is the difference between the Cost of computers, communications and other services (% of commerical service exports) in Marshall Islands and Cost of computers, communications and other services (% of commerical service exports) in Mozambique?
Ensure brevity in your answer.  -37.92. In the year 2012, what is the difference between the Cost of computers, communications and other services (% of commerical service exports) in Sub-Saharan Africa (developing only) and Cost of computers, communications and other services (% of commerical service exports) in Marshall Islands?
Give a very brief answer. 4.49. In the year 2012, what is the difference between the Cost of computers, communications and other services (% of commerical service exports) of Sub-Saharan Africa (developing only) and Cost of computers, communications and other services (% of commerical service exports) of Mozambique?
Your response must be concise. -44.4. In the year 2012, what is the difference between the Cost of computers, communications and other services (% of commerical service exports) of Marshall Islands and Cost of computers, communications and other services (% of commerical service exports) of Mozambique?
Your response must be concise. -48.89. What is the ratio of the Cost of computers, communications and other services (% of commerical service exports) of Sub-Saharan Africa (developing only) in 2005 to that in 2006?
Provide a short and direct response. 1.01. What is the ratio of the Cost of computers, communications and other services (% of commerical service exports) in Marshall Islands in 2005 to that in 2006?
Give a very brief answer. 0.89. What is the ratio of the Cost of computers, communications and other services (% of commerical service exports) of Mozambique in 2005 to that in 2006?
Give a very brief answer. 0.88. What is the ratio of the Cost of computers, communications and other services (% of commerical service exports) in Sub-Saharan Africa (developing only) in 2005 to that in 2007?
Make the answer very short. 1.04. What is the ratio of the Cost of computers, communications and other services (% of commerical service exports) of Marshall Islands in 2005 to that in 2007?
Your response must be concise. 0.66. What is the ratio of the Cost of computers, communications and other services (% of commerical service exports) in Mozambique in 2005 to that in 2007?
Provide a succinct answer. 0.82. What is the ratio of the Cost of computers, communications and other services (% of commerical service exports) of Sub-Saharan Africa (developing only) in 2005 to that in 2008?
Your answer should be compact. 1.09. What is the ratio of the Cost of computers, communications and other services (% of commerical service exports) in Marshall Islands in 2005 to that in 2008?
Your answer should be compact. 1.01. What is the ratio of the Cost of computers, communications and other services (% of commerical service exports) of Mozambique in 2005 to that in 2008?
Offer a very short reply. 0.94. What is the ratio of the Cost of computers, communications and other services (% of commerical service exports) in Sub-Saharan Africa (developing only) in 2005 to that in 2009?
Provide a short and direct response. 0.93. What is the ratio of the Cost of computers, communications and other services (% of commerical service exports) of Marshall Islands in 2005 to that in 2009?
Your response must be concise. 0.4. What is the ratio of the Cost of computers, communications and other services (% of commerical service exports) in Mozambique in 2005 to that in 2009?
Keep it short and to the point. 0.81. What is the ratio of the Cost of computers, communications and other services (% of commerical service exports) of Marshall Islands in 2005 to that in 2010?
Offer a very short reply. 0.62. What is the ratio of the Cost of computers, communications and other services (% of commerical service exports) in Mozambique in 2005 to that in 2010?
Provide a succinct answer. 0.71. What is the ratio of the Cost of computers, communications and other services (% of commerical service exports) of Sub-Saharan Africa (developing only) in 2005 to that in 2011?
Provide a short and direct response. 0.91. What is the ratio of the Cost of computers, communications and other services (% of commerical service exports) in Marshall Islands in 2005 to that in 2011?
Your answer should be very brief. 0.62. What is the ratio of the Cost of computers, communications and other services (% of commerical service exports) in Mozambique in 2005 to that in 2011?
Make the answer very short. 0.52. What is the ratio of the Cost of computers, communications and other services (% of commerical service exports) of Sub-Saharan Africa (developing only) in 2005 to that in 2012?
Provide a short and direct response. 0.91. What is the ratio of the Cost of computers, communications and other services (% of commerical service exports) of Marshall Islands in 2005 to that in 2012?
Provide a succinct answer. 0.56. What is the ratio of the Cost of computers, communications and other services (% of commerical service exports) in Mozambique in 2005 to that in 2012?
Offer a terse response. 0.43. What is the ratio of the Cost of computers, communications and other services (% of commerical service exports) of Sub-Saharan Africa (developing only) in 2006 to that in 2007?
Your answer should be very brief. 1.03. What is the ratio of the Cost of computers, communications and other services (% of commerical service exports) of Marshall Islands in 2006 to that in 2007?
Give a very brief answer. 0.74. What is the ratio of the Cost of computers, communications and other services (% of commerical service exports) in Mozambique in 2006 to that in 2007?
Provide a short and direct response. 0.93. What is the ratio of the Cost of computers, communications and other services (% of commerical service exports) in Sub-Saharan Africa (developing only) in 2006 to that in 2008?
Your response must be concise. 1.08. What is the ratio of the Cost of computers, communications and other services (% of commerical service exports) in Marshall Islands in 2006 to that in 2008?
Make the answer very short. 1.14. What is the ratio of the Cost of computers, communications and other services (% of commerical service exports) of Mozambique in 2006 to that in 2008?
Make the answer very short. 1.07. What is the ratio of the Cost of computers, communications and other services (% of commerical service exports) of Sub-Saharan Africa (developing only) in 2006 to that in 2009?
Offer a terse response. 0.92. What is the ratio of the Cost of computers, communications and other services (% of commerical service exports) of Marshall Islands in 2006 to that in 2009?
Give a very brief answer. 0.45. What is the ratio of the Cost of computers, communications and other services (% of commerical service exports) in Mozambique in 2006 to that in 2009?
Ensure brevity in your answer.  0.92. What is the ratio of the Cost of computers, communications and other services (% of commerical service exports) of Sub-Saharan Africa (developing only) in 2006 to that in 2010?
Offer a very short reply. 0.9. What is the ratio of the Cost of computers, communications and other services (% of commerical service exports) in Marshall Islands in 2006 to that in 2010?
Provide a succinct answer. 0.71. What is the ratio of the Cost of computers, communications and other services (% of commerical service exports) of Mozambique in 2006 to that in 2010?
Offer a very short reply. 0.81. What is the ratio of the Cost of computers, communications and other services (% of commerical service exports) in Sub-Saharan Africa (developing only) in 2006 to that in 2011?
Provide a short and direct response. 0.9. What is the ratio of the Cost of computers, communications and other services (% of commerical service exports) of Marshall Islands in 2006 to that in 2011?
Make the answer very short. 0.7. What is the ratio of the Cost of computers, communications and other services (% of commerical service exports) of Mozambique in 2006 to that in 2011?
Offer a terse response. 0.59. What is the ratio of the Cost of computers, communications and other services (% of commerical service exports) in Sub-Saharan Africa (developing only) in 2006 to that in 2012?
Your answer should be very brief. 0.9. What is the ratio of the Cost of computers, communications and other services (% of commerical service exports) of Marshall Islands in 2006 to that in 2012?
Make the answer very short. 0.63. What is the ratio of the Cost of computers, communications and other services (% of commerical service exports) in Mozambique in 2006 to that in 2012?
Your response must be concise. 0.48. What is the ratio of the Cost of computers, communications and other services (% of commerical service exports) in Sub-Saharan Africa (developing only) in 2007 to that in 2008?
Keep it short and to the point. 1.05. What is the ratio of the Cost of computers, communications and other services (% of commerical service exports) of Marshall Islands in 2007 to that in 2008?
Ensure brevity in your answer.  1.55. What is the ratio of the Cost of computers, communications and other services (% of commerical service exports) of Mozambique in 2007 to that in 2008?
Keep it short and to the point. 1.15. What is the ratio of the Cost of computers, communications and other services (% of commerical service exports) of Sub-Saharan Africa (developing only) in 2007 to that in 2009?
Offer a very short reply. 0.89. What is the ratio of the Cost of computers, communications and other services (% of commerical service exports) of Marshall Islands in 2007 to that in 2009?
Your response must be concise. 0.61. What is the ratio of the Cost of computers, communications and other services (% of commerical service exports) in Mozambique in 2007 to that in 2009?
Keep it short and to the point. 0.99. What is the ratio of the Cost of computers, communications and other services (% of commerical service exports) of Sub-Saharan Africa (developing only) in 2007 to that in 2010?
Ensure brevity in your answer.  0.88. What is the ratio of the Cost of computers, communications and other services (% of commerical service exports) in Marshall Islands in 2007 to that in 2010?
Your response must be concise. 0.95. What is the ratio of the Cost of computers, communications and other services (% of commerical service exports) of Mozambique in 2007 to that in 2010?
Your answer should be very brief. 0.87. What is the ratio of the Cost of computers, communications and other services (% of commerical service exports) of Sub-Saharan Africa (developing only) in 2007 to that in 2011?
Provide a succinct answer. 0.88. What is the ratio of the Cost of computers, communications and other services (% of commerical service exports) of Marshall Islands in 2007 to that in 2011?
Your answer should be compact. 0.95. What is the ratio of the Cost of computers, communications and other services (% of commerical service exports) in Mozambique in 2007 to that in 2011?
Keep it short and to the point. 0.64. What is the ratio of the Cost of computers, communications and other services (% of commerical service exports) in Sub-Saharan Africa (developing only) in 2007 to that in 2012?
Your response must be concise. 0.88. What is the ratio of the Cost of computers, communications and other services (% of commerical service exports) in Marshall Islands in 2007 to that in 2012?
Your response must be concise. 0.85. What is the ratio of the Cost of computers, communications and other services (% of commerical service exports) of Mozambique in 2007 to that in 2012?
Your response must be concise. 0.52. What is the ratio of the Cost of computers, communications and other services (% of commerical service exports) of Sub-Saharan Africa (developing only) in 2008 to that in 2009?
Your answer should be very brief. 0.85. What is the ratio of the Cost of computers, communications and other services (% of commerical service exports) of Marshall Islands in 2008 to that in 2009?
Your answer should be compact. 0.4. What is the ratio of the Cost of computers, communications and other services (% of commerical service exports) in Mozambique in 2008 to that in 2009?
Provide a succinct answer. 0.86. What is the ratio of the Cost of computers, communications and other services (% of commerical service exports) in Sub-Saharan Africa (developing only) in 2008 to that in 2010?
Keep it short and to the point. 0.84. What is the ratio of the Cost of computers, communications and other services (% of commerical service exports) in Marshall Islands in 2008 to that in 2010?
Provide a short and direct response. 0.62. What is the ratio of the Cost of computers, communications and other services (% of commerical service exports) in Mozambique in 2008 to that in 2010?
Your answer should be very brief. 0.76. What is the ratio of the Cost of computers, communications and other services (% of commerical service exports) of Sub-Saharan Africa (developing only) in 2008 to that in 2011?
Give a very brief answer. 0.83. What is the ratio of the Cost of computers, communications and other services (% of commerical service exports) in Marshall Islands in 2008 to that in 2011?
Ensure brevity in your answer.  0.61. What is the ratio of the Cost of computers, communications and other services (% of commerical service exports) in Mozambique in 2008 to that in 2011?
Give a very brief answer. 0.55. What is the ratio of the Cost of computers, communications and other services (% of commerical service exports) in Sub-Saharan Africa (developing only) in 2008 to that in 2012?
Give a very brief answer. 0.83. What is the ratio of the Cost of computers, communications and other services (% of commerical service exports) in Marshall Islands in 2008 to that in 2012?
Your answer should be compact. 0.55. What is the ratio of the Cost of computers, communications and other services (% of commerical service exports) of Mozambique in 2008 to that in 2012?
Your response must be concise. 0.45. What is the ratio of the Cost of computers, communications and other services (% of commerical service exports) of Marshall Islands in 2009 to that in 2010?
Offer a terse response. 1.55. What is the ratio of the Cost of computers, communications and other services (% of commerical service exports) in Mozambique in 2009 to that in 2010?
Offer a terse response. 0.88. What is the ratio of the Cost of computers, communications and other services (% of commerical service exports) of Sub-Saharan Africa (developing only) in 2009 to that in 2011?
Your answer should be compact. 0.98. What is the ratio of the Cost of computers, communications and other services (% of commerical service exports) in Marshall Islands in 2009 to that in 2011?
Offer a terse response. 1.54. What is the ratio of the Cost of computers, communications and other services (% of commerical service exports) in Mozambique in 2009 to that in 2011?
Offer a terse response. 0.64. What is the ratio of the Cost of computers, communications and other services (% of commerical service exports) in Sub-Saharan Africa (developing only) in 2009 to that in 2012?
Keep it short and to the point. 0.98. What is the ratio of the Cost of computers, communications and other services (% of commerical service exports) in Marshall Islands in 2009 to that in 2012?
Ensure brevity in your answer.  1.39. What is the ratio of the Cost of computers, communications and other services (% of commerical service exports) of Mozambique in 2009 to that in 2012?
Your answer should be compact. 0.53. What is the ratio of the Cost of computers, communications and other services (% of commerical service exports) of Sub-Saharan Africa (developing only) in 2010 to that in 2011?
Your answer should be very brief. 1. What is the ratio of the Cost of computers, communications and other services (% of commerical service exports) of Mozambique in 2010 to that in 2011?
Give a very brief answer. 0.73. What is the ratio of the Cost of computers, communications and other services (% of commerical service exports) in Sub-Saharan Africa (developing only) in 2010 to that in 2012?
Keep it short and to the point. 1. What is the ratio of the Cost of computers, communications and other services (% of commerical service exports) in Marshall Islands in 2010 to that in 2012?
Your answer should be very brief. 0.89. What is the ratio of the Cost of computers, communications and other services (% of commerical service exports) of Mozambique in 2010 to that in 2012?
Give a very brief answer. 0.6. What is the ratio of the Cost of computers, communications and other services (% of commerical service exports) of Marshall Islands in 2011 to that in 2012?
Ensure brevity in your answer.  0.9. What is the ratio of the Cost of computers, communications and other services (% of commerical service exports) of Mozambique in 2011 to that in 2012?
Keep it short and to the point. 0.82. What is the difference between the highest and the second highest Cost of computers, communications and other services (% of commerical service exports) of Sub-Saharan Africa (developing only)?
Offer a terse response. 0.01. What is the difference between the highest and the second highest Cost of computers, communications and other services (% of commerical service exports) of Marshall Islands?
Your answer should be very brief. 10.23. What is the difference between the highest and the second highest Cost of computers, communications and other services (% of commerical service exports) in Mozambique?
Your response must be concise. 13.71. What is the difference between the highest and the lowest Cost of computers, communications and other services (% of commerical service exports) of Sub-Saharan Africa (developing only)?
Give a very brief answer. 5.16. What is the difference between the highest and the lowest Cost of computers, communications and other services (% of commerical service exports) in Marshall Islands?
Provide a succinct answer. 22.18. What is the difference between the highest and the lowest Cost of computers, communications and other services (% of commerical service exports) in Mozambique?
Your answer should be very brief. 43.35. 